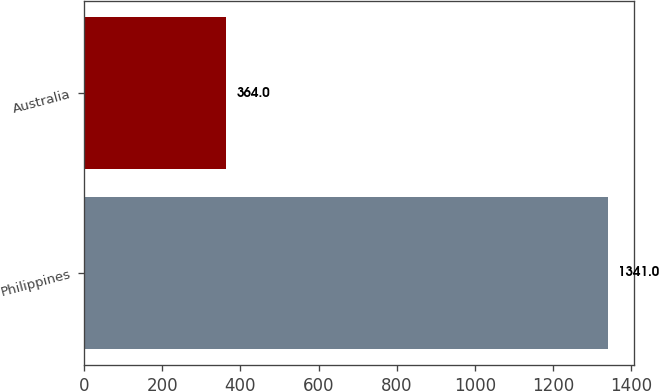<chart> <loc_0><loc_0><loc_500><loc_500><bar_chart><fcel>Philippines<fcel>Australia<nl><fcel>1341<fcel>364<nl></chart> 